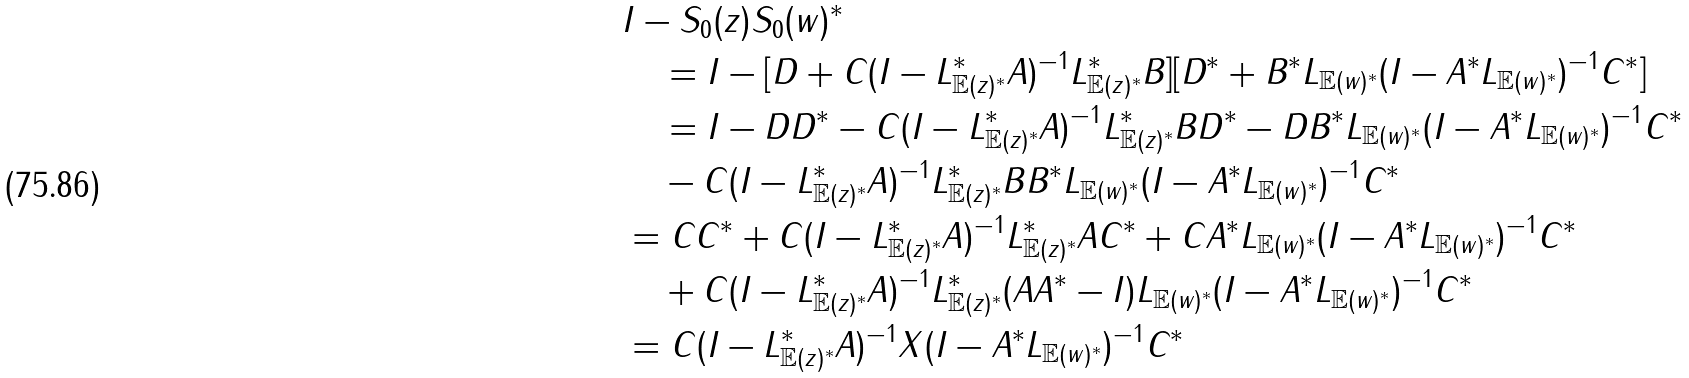Convert formula to latex. <formula><loc_0><loc_0><loc_500><loc_500>& I - S _ { 0 } ( z ) S _ { 0 } ( w ) ^ { * } \\ & \quad = I - [ D + C ( I - L _ { { \mathbb { E } } ( z ) ^ { * } } ^ { * } A ) ^ { - 1 } L ^ { * } _ { { \mathbb { E } } ( z ) ^ { * } } B ] [ D ^ { * } + B ^ { * } L _ { { \mathbb { E } } ( w ) ^ { * } } ( I - A ^ { * } L _ { { \mathbb { E } } ( w ) ^ { * } } ) ^ { - 1 } C ^ { * } ] \\ & \quad = I - D D ^ { * } - C ( I - L _ { { \mathbb { E } } ( z ) ^ { * } } ^ { * } A ) ^ { - 1 } L ^ { * } _ { { \mathbb { E } } ( z ) ^ { * } } B D ^ { * } - D B ^ { * } L _ { { \mathbb { E } } ( w ) ^ { * } } ( I - A ^ { * } L _ { { \mathbb { E } } ( w ) ^ { * } } ) ^ { - 1 } C ^ { * } \\ & \quad - C ( I - L _ { { \mathbb { E } } ( z ) ^ { * } } ^ { * } A ) ^ { - 1 } L ^ { * } _ { { \mathbb { E } } ( z ) ^ { * } } B B ^ { * } L _ { { \mathbb { E } } ( w ) ^ { * } } ( I - A ^ { * } L _ { { \mathbb { E } } ( w ) ^ { * } } ) ^ { - 1 } C ^ { * } \\ & = C C ^ { * } + C ( I - L _ { { \mathbb { E } } ( z ) ^ { * } } ^ { * } A ) ^ { - 1 } L ^ { * } _ { { \mathbb { E } } ( z ) ^ { * } } A C ^ { * } + C A ^ { * } L _ { { \mathbb { E } } ( w ) ^ { * } } ( I - A ^ { * } L _ { { \mathbb { E } } ( w ) ^ { * } } ) ^ { - 1 } C ^ { * } \\ & \quad + C ( I - L _ { { \mathbb { E } } ( z ) ^ { * } } ^ { * } A ) ^ { - 1 } L ^ { * } _ { { \mathbb { E } } ( z ) ^ { * } } ( A A ^ { * } - I ) L _ { { \mathbb { E } } ( w ) ^ { * } } ( I - A ^ { * } L _ { { \mathbb { E } } ( w ) ^ { * } } ) ^ { - 1 } C ^ { * } \\ & = C ( I - L ^ { * } _ { { \mathbb { E } } ( z ) ^ { * } } A ) ^ { - 1 } X ( I - A ^ { * } L _ { { \mathbb { E } } ( w ) ^ { * } } ) ^ { - 1 } C ^ { * }</formula> 